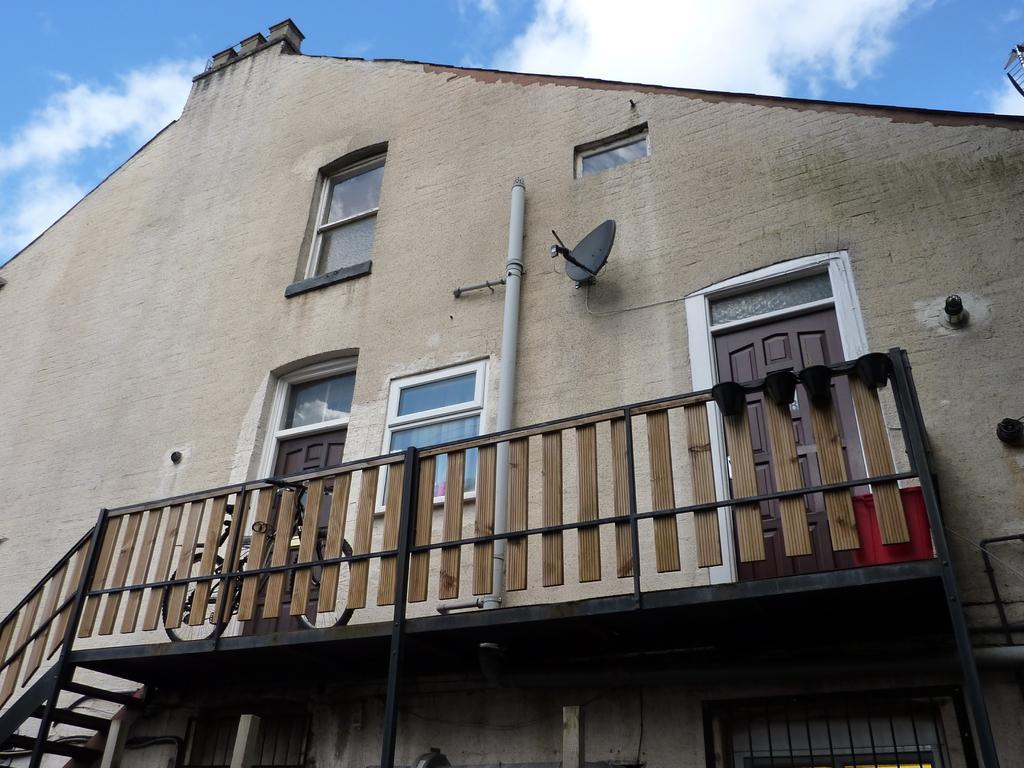How would you summarize this image in a sentence or two? In this image we can see buildings with windows, railing and we can also see the sky. 